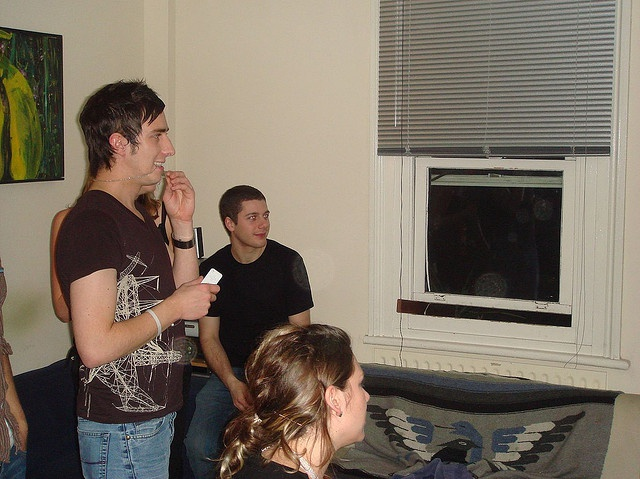Describe the objects in this image and their specific colors. I can see people in darkgray, black, gray, and tan tones, couch in darkgray, gray, and black tones, tv in darkgray, black, and gray tones, people in darkgray, black, maroon, tan, and gray tones, and people in darkgray, black, brown, and maroon tones in this image. 